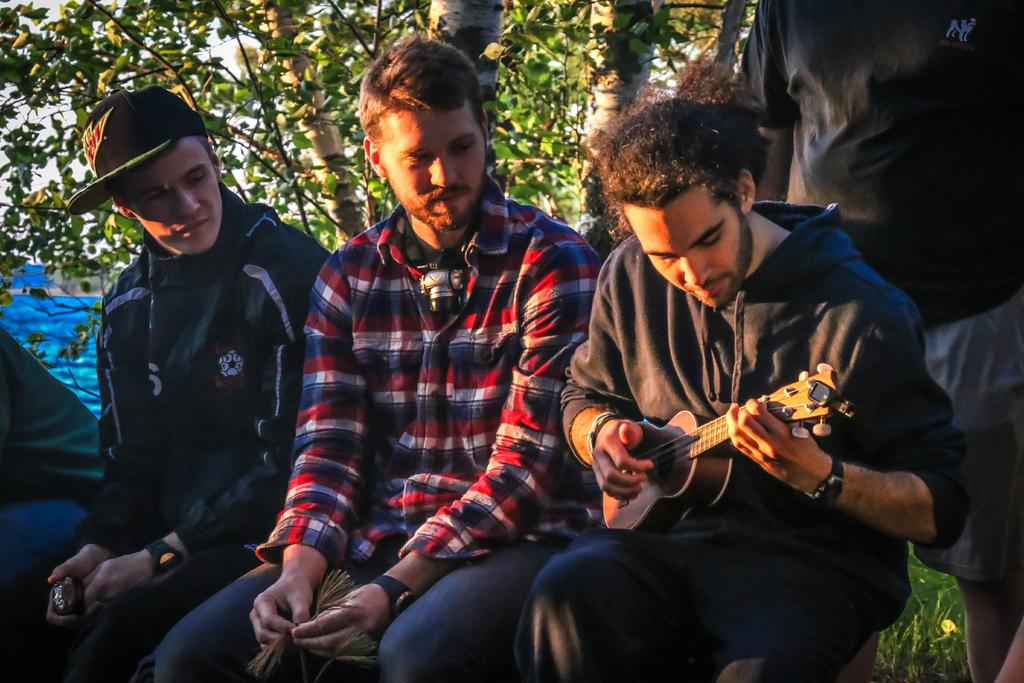What type of natural element can be seen in the image? There is a tree in the image. How many people are present in the image? There are four people in the image. What are the positions of the people in the image? Three of the people are sitting, and one is not specified. What is one of the sitting people holding? One of the sitting people is holding a guitar. What type of paper is being used to write a comforting note in the image? There is no paper or note present in the image. 